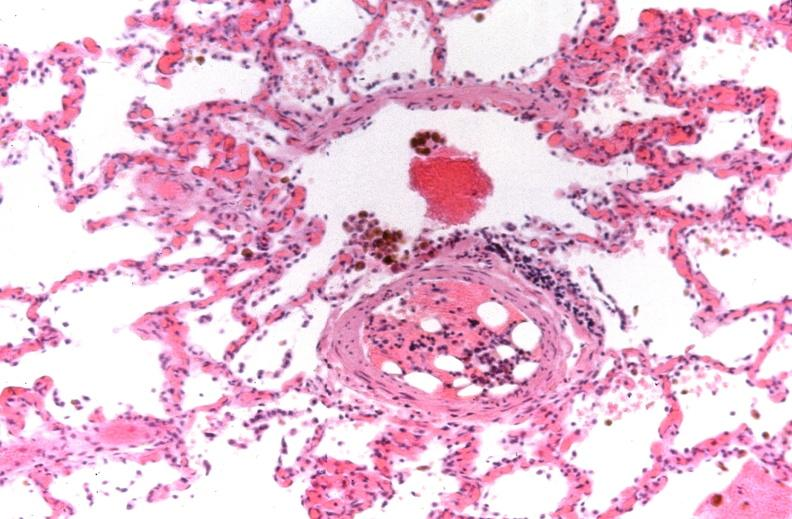does fibrinous peritonitis show lung, congestive heart failure, bone marrow embolus?
Answer the question using a single word or phrase. No 